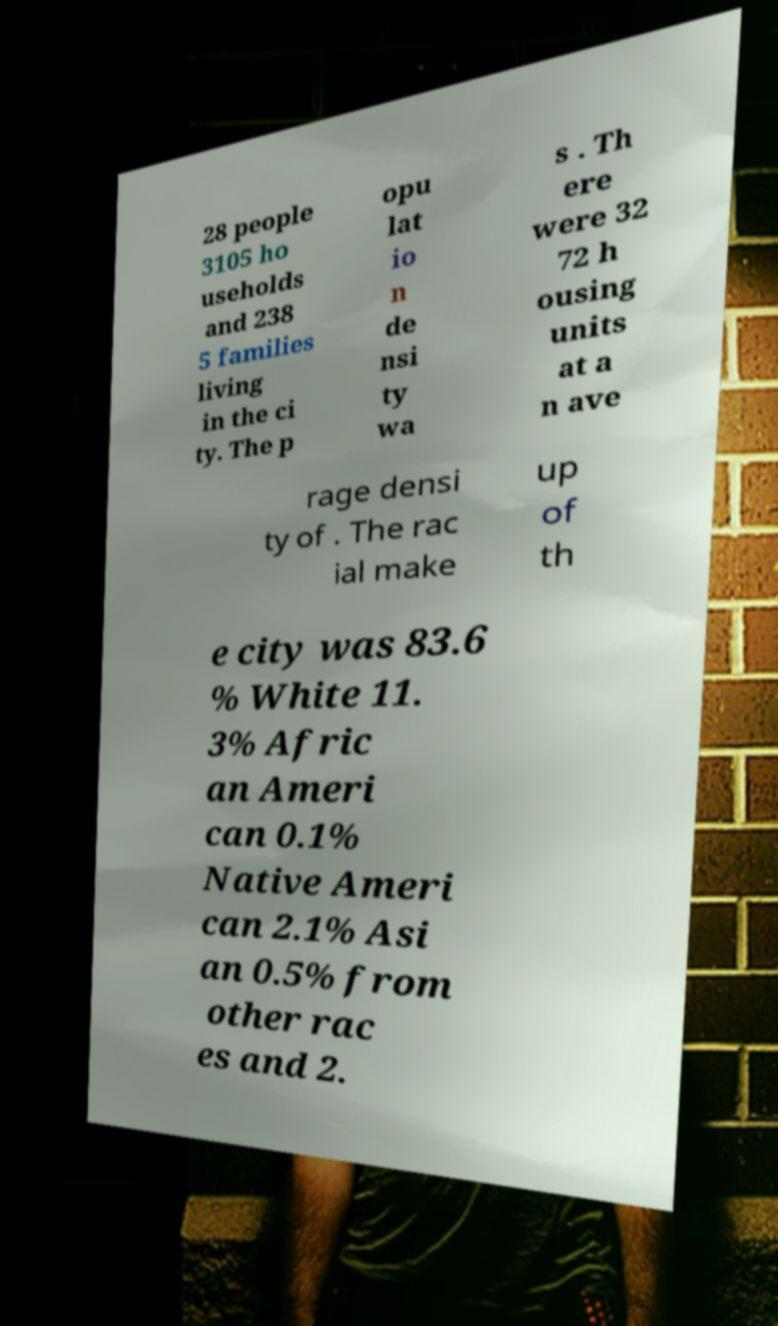There's text embedded in this image that I need extracted. Can you transcribe it verbatim? 28 people 3105 ho useholds and 238 5 families living in the ci ty. The p opu lat io n de nsi ty wa s . Th ere were 32 72 h ousing units at a n ave rage densi ty of . The rac ial make up of th e city was 83.6 % White 11. 3% Afric an Ameri can 0.1% Native Ameri can 2.1% Asi an 0.5% from other rac es and 2. 